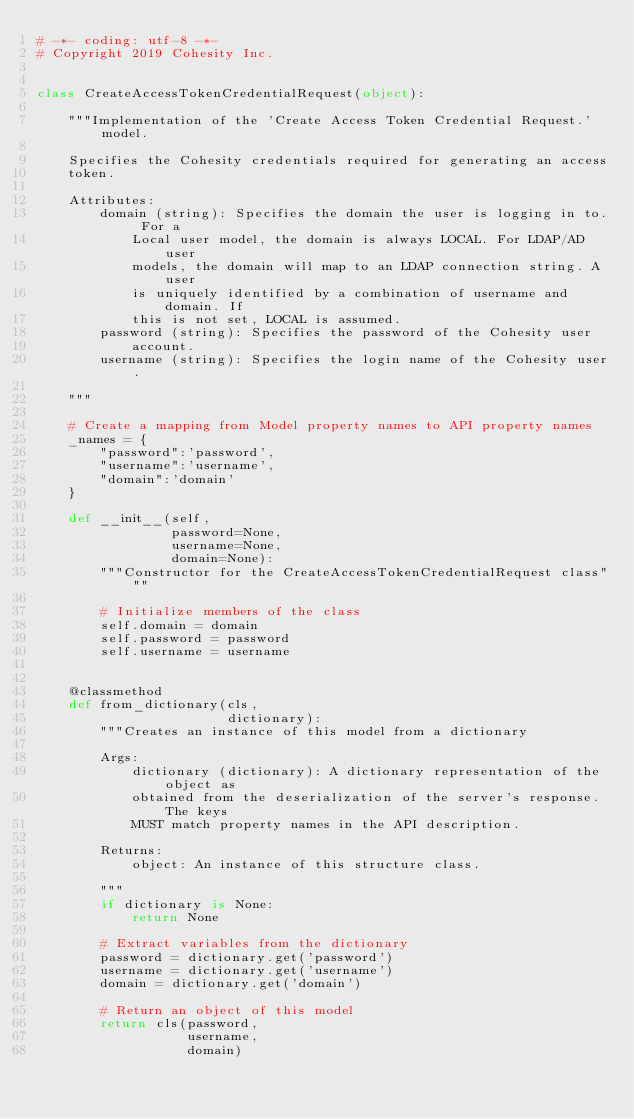Convert code to text. <code><loc_0><loc_0><loc_500><loc_500><_Python_># -*- coding: utf-8 -*-
# Copyright 2019 Cohesity Inc.


class CreateAccessTokenCredentialRequest(object):

    """Implementation of the 'Create Access Token Credential Request.' model.

    Specifies the Cohesity credentials required for generating an access
    token.

    Attributes:
        domain (string): Specifies the domain the user is logging in to. For a
            Local user model, the domain is always LOCAL. For LDAP/AD user
            models, the domain will map to an LDAP connection string. A user
            is uniquely identified by a combination of username and domain. If
            this is not set, LOCAL is assumed.
        password (string): Specifies the password of the Cohesity user
            account.
        username (string): Specifies the login name of the Cohesity user.

    """

    # Create a mapping from Model property names to API property names
    _names = {
        "password":'password',
        "username":'username',
        "domain":'domain'
    }

    def __init__(self,
                 password=None,
                 username=None,
                 domain=None):
        """Constructor for the CreateAccessTokenCredentialRequest class"""

        # Initialize members of the class
        self.domain = domain
        self.password = password
        self.username = username


    @classmethod
    def from_dictionary(cls,
                        dictionary):
        """Creates an instance of this model from a dictionary

        Args:
            dictionary (dictionary): A dictionary representation of the object as
            obtained from the deserialization of the server's response. The keys
            MUST match property names in the API description.

        Returns:
            object: An instance of this structure class.

        """
        if dictionary is None:
            return None

        # Extract variables from the dictionary
        password = dictionary.get('password')
        username = dictionary.get('username')
        domain = dictionary.get('domain')

        # Return an object of this model
        return cls(password,
                   username,
                   domain)


</code> 